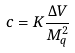Convert formula to latex. <formula><loc_0><loc_0><loc_500><loc_500>c = K \frac { \Delta V } { M _ { q } ^ { 2 } }</formula> 